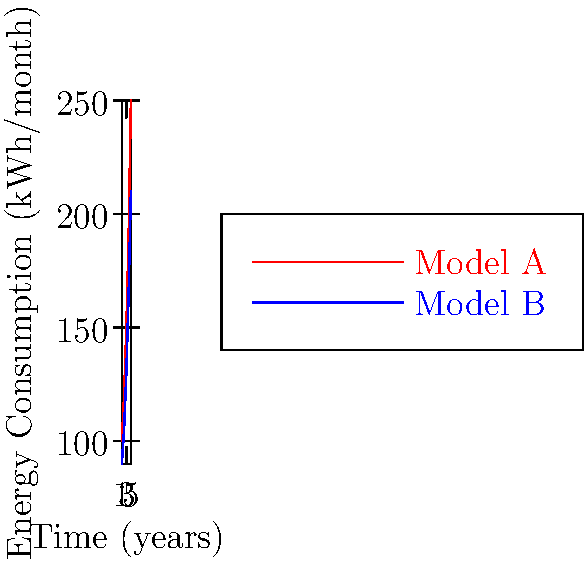As a cashier familiar with refrigeration systems in grocery stores, analyze the graph showing energy consumption of two refrigerator models over time. If Haggen had chosen Model B instead of Model A, what would be the approximate total energy savings (in kWh) over a 5-year period? To solve this problem, we need to follow these steps:

1. Calculate the total energy consumption for Model A over 5 years:
   Year 1: 100 kWh/month
   Year 2: 120 kWh/month
   Year 3: 150 kWh/month
   Year 4: 190 kWh/month
   Year 5: 250 kWh/month
   Total A = $(100 + 120 + 150 + 190 + 250) \times 12$ = $9720$ kWh

2. Calculate the total energy consumption for Model B over 5 years:
   Year 1: 90 kWh/month
   Year 2: 105 kWh/month
   Year 3: 130 kWh/month
   Year 4: 165 kWh/month
   Year 5: 210 kWh/month
   Total B = $(90 + 105 + 130 + 165 + 210) \times 12$ = $8400$ kWh

3. Calculate the difference between Model A and Model B:
   Energy savings = Total A - Total B
   $9720 - 8400 = 1320$ kWh

Therefore, the approximate total energy savings over a 5-year period would be 1320 kWh.
Answer: 1320 kWh 